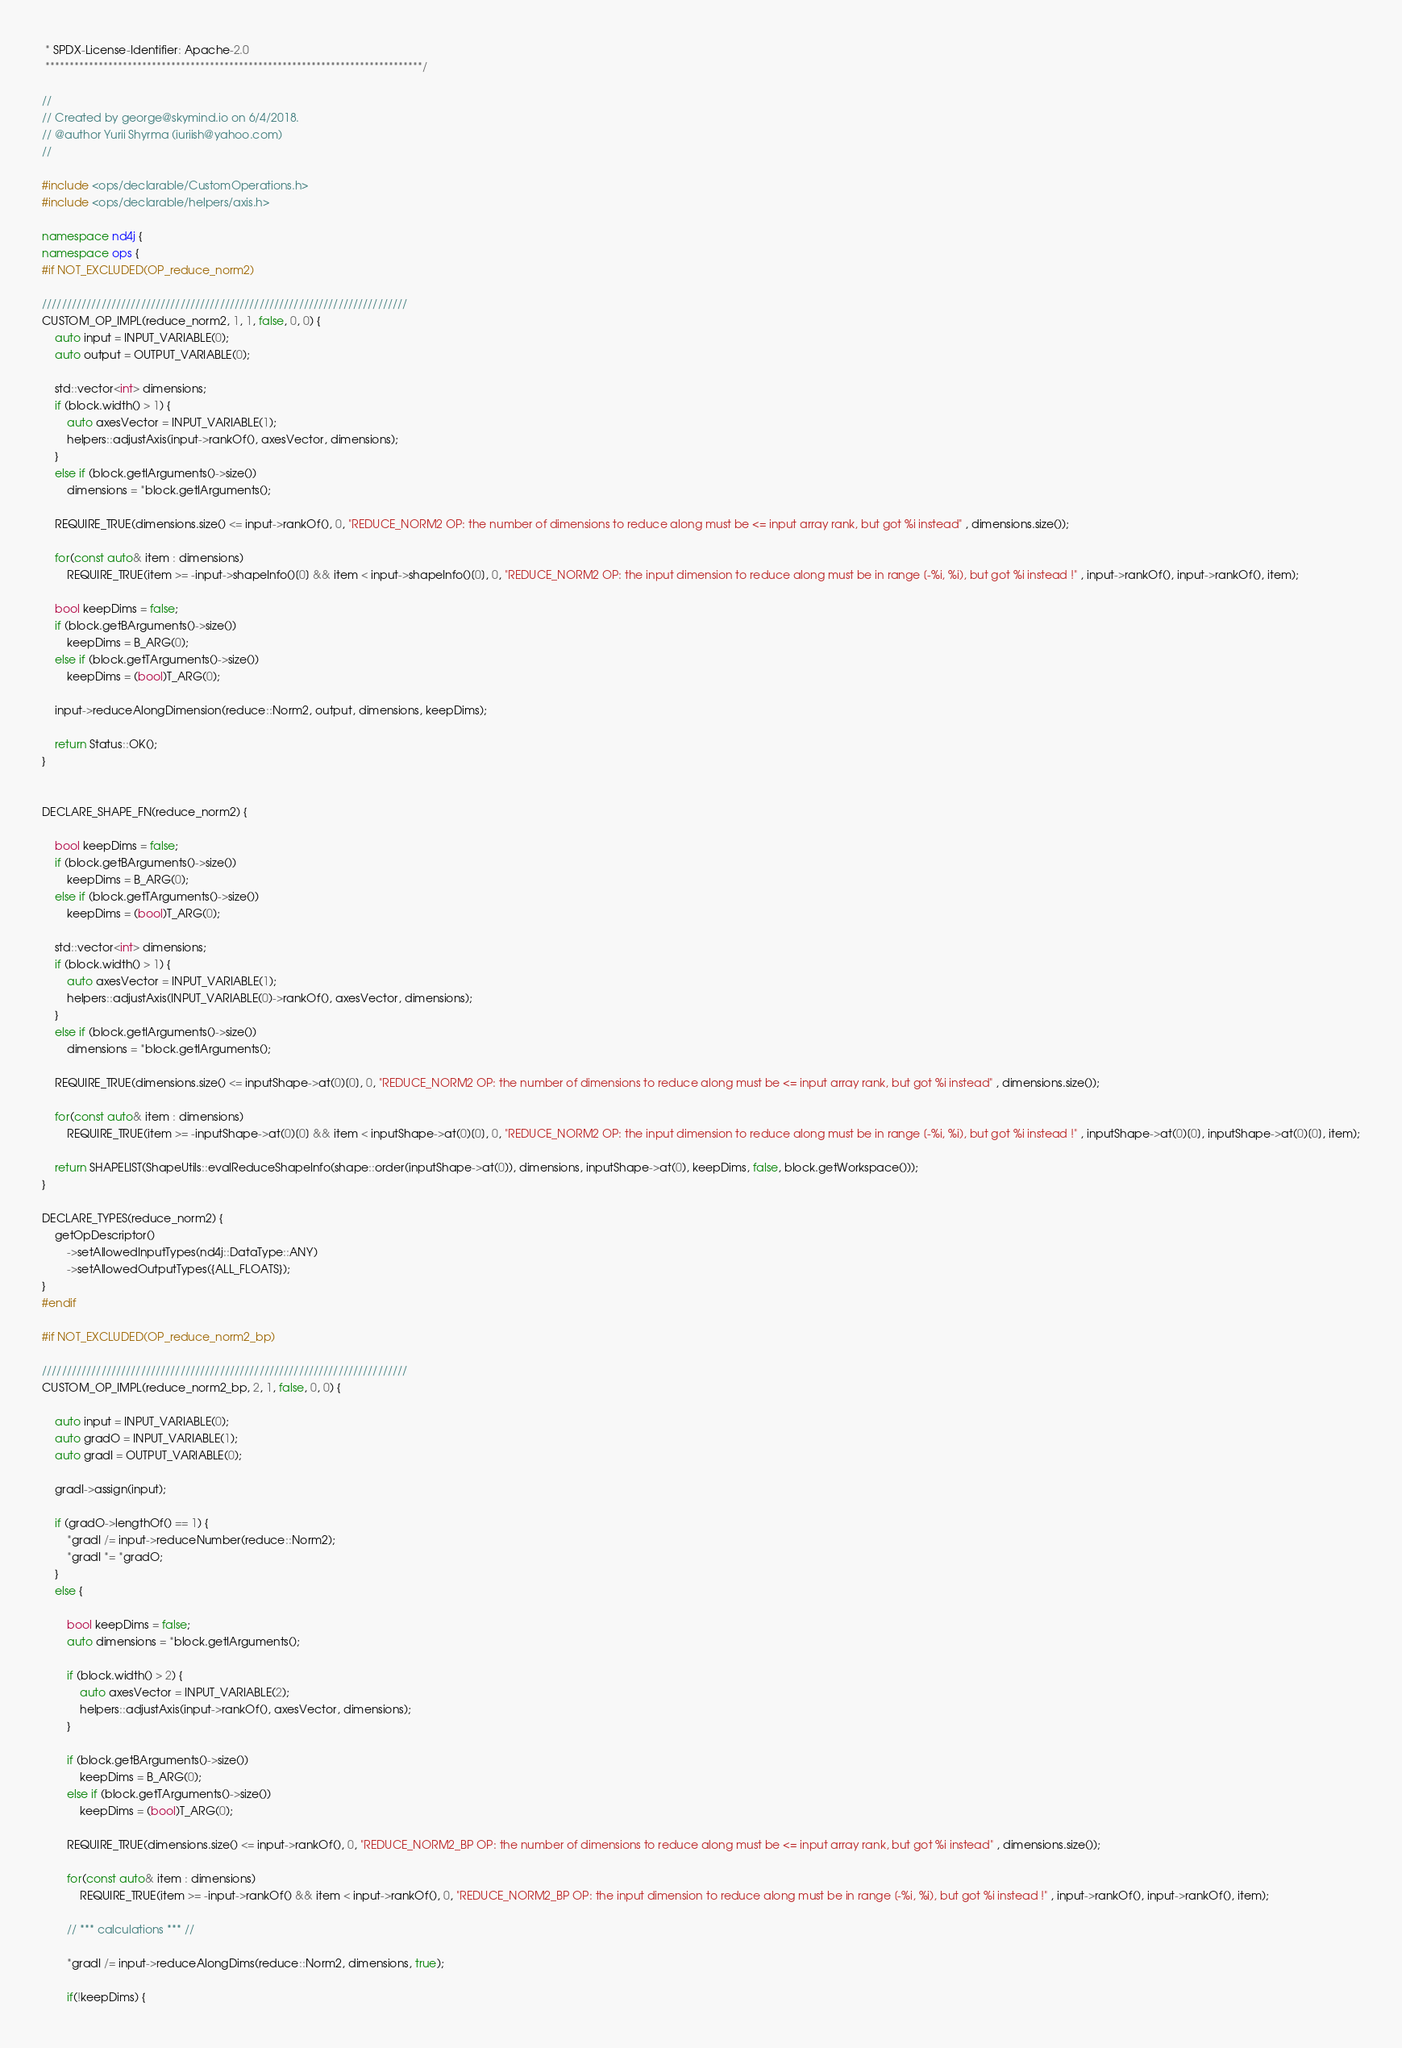Convert code to text. <code><loc_0><loc_0><loc_500><loc_500><_C++_> * SPDX-License-Identifier: Apache-2.0
 ******************************************************************************/

//
// Created by george@skymind.io on 6/4/2018.
// @author Yurii Shyrma (iuriish@yahoo.com)
//

#include <ops/declarable/CustomOperations.h>
#include <ops/declarable/helpers/axis.h>

namespace nd4j {
namespace ops {
#if NOT_EXCLUDED(OP_reduce_norm2)

//////////////////////////////////////////////////////////////////////////
CUSTOM_OP_IMPL(reduce_norm2, 1, 1, false, 0, 0) {
    auto input = INPUT_VARIABLE(0);
    auto output = OUTPUT_VARIABLE(0);

    std::vector<int> dimensions;
    if (block.width() > 1) {
        auto axesVector = INPUT_VARIABLE(1);
        helpers::adjustAxis(input->rankOf(), axesVector, dimensions);
    }
    else if (block.getIArguments()->size())
        dimensions = *block.getIArguments();

    REQUIRE_TRUE(dimensions.size() <= input->rankOf(), 0, "REDUCE_NORM2 OP: the number of dimensions to reduce along must be <= input array rank, but got %i instead" , dimensions.size());

    for(const auto& item : dimensions)
        REQUIRE_TRUE(item >= -input->shapeInfo()[0] && item < input->shapeInfo()[0], 0, "REDUCE_NORM2 OP: the input dimension to reduce along must be in range [-%i, %i), but got %i instead !" , input->rankOf(), input->rankOf(), item);

    bool keepDims = false;
    if (block.getBArguments()->size())
        keepDims = B_ARG(0);
    else if (block.getTArguments()->size())
        keepDims = (bool)T_ARG(0);

    input->reduceAlongDimension(reduce::Norm2, output, dimensions, keepDims);

    return Status::OK();
}


DECLARE_SHAPE_FN(reduce_norm2) {

    bool keepDims = false;
    if (block.getBArguments()->size())
        keepDims = B_ARG(0);
    else if (block.getTArguments()->size())
        keepDims = (bool)T_ARG(0);

    std::vector<int> dimensions;
    if (block.width() > 1) {
        auto axesVector = INPUT_VARIABLE(1);
        helpers::adjustAxis(INPUT_VARIABLE(0)->rankOf(), axesVector, dimensions);
    }
    else if (block.getIArguments()->size())
        dimensions = *block.getIArguments();

    REQUIRE_TRUE(dimensions.size() <= inputShape->at(0)[0], 0, "REDUCE_NORM2 OP: the number of dimensions to reduce along must be <= input array rank, but got %i instead" , dimensions.size());

    for(const auto& item : dimensions)
        REQUIRE_TRUE(item >= -inputShape->at(0)[0] && item < inputShape->at(0)[0], 0, "REDUCE_NORM2 OP: the input dimension to reduce along must be in range [-%i, %i), but got %i instead !" , inputShape->at(0)[0], inputShape->at(0)[0], item);

    return SHAPELIST(ShapeUtils::evalReduceShapeInfo(shape::order(inputShape->at(0)), dimensions, inputShape->at(0), keepDims, false, block.getWorkspace()));
}

DECLARE_TYPES(reduce_norm2) {
    getOpDescriptor()
        ->setAllowedInputTypes(nd4j::DataType::ANY)
        ->setAllowedOutputTypes({ALL_FLOATS});
}
#endif

#if NOT_EXCLUDED(OP_reduce_norm2_bp)

//////////////////////////////////////////////////////////////////////////
CUSTOM_OP_IMPL(reduce_norm2_bp, 2, 1, false, 0, 0) {

    auto input = INPUT_VARIABLE(0);
    auto gradO = INPUT_VARIABLE(1);
    auto gradI = OUTPUT_VARIABLE(0);

    gradI->assign(input);

    if (gradO->lengthOf() == 1) {
        *gradI /= input->reduceNumber(reduce::Norm2);
        *gradI *= *gradO;
    }
    else {

        bool keepDims = false;
        auto dimensions = *block.getIArguments();

        if (block.width() > 2) {
            auto axesVector = INPUT_VARIABLE(2);
            helpers::adjustAxis(input->rankOf(), axesVector, dimensions);
        }

        if (block.getBArguments()->size())
            keepDims = B_ARG(0);
        else if (block.getTArguments()->size())
            keepDims = (bool)T_ARG(0);

        REQUIRE_TRUE(dimensions.size() <= input->rankOf(), 0, "REDUCE_NORM2_BP OP: the number of dimensions to reduce along must be <= input array rank, but got %i instead" , dimensions.size());

        for(const auto& item : dimensions)
            REQUIRE_TRUE(item >= -input->rankOf() && item < input->rankOf(), 0, "REDUCE_NORM2_BP OP: the input dimension to reduce along must be in range [-%i, %i), but got %i instead !" , input->rankOf(), input->rankOf(), item);

        // *** calculations *** //

        *gradI /= input->reduceAlongDims(reduce::Norm2, dimensions, true);

        if(!keepDims) {</code> 